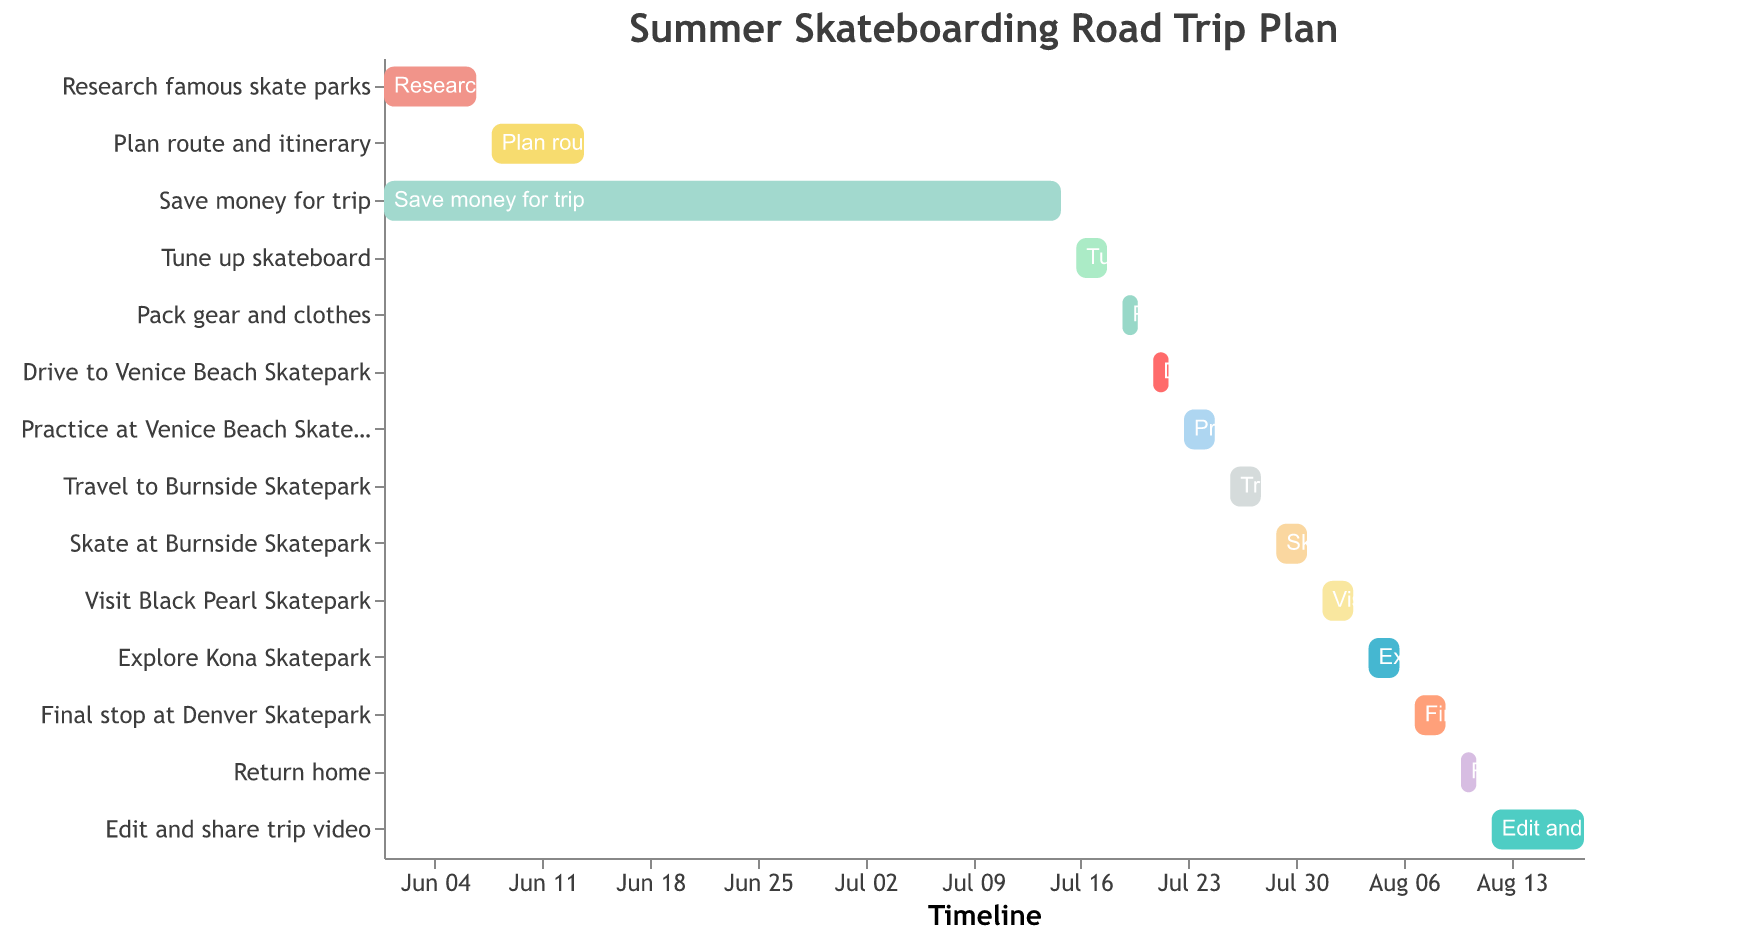How long is the "Save money for trip" task? Find the "Save money for trip" bar and check the duration in the corresponding row.
Answer: 45 days What is the first task in the planning process? The figure's y-axis lists tasks chronologically from top to bottom. The top task is "Research famous skate parks".
Answer: Research famous skate parks Which task has the shortest duration? Compare the durations listed for all tasks. "Pack gear and clothes" has the shortest duration of 2 days.
Answer: Pack gear and clothes What is the total duration of the travel tasks? Sum the durations of the travel-related tasks: Drive to Venice Beach Skatepark (2) + Travel to Burnside Skatepark (3) + Return home (2) = 7.
Answer: 7 days Which task ends latest in August? Check the end dates of tasks listed in August. The last task "Edit and share trip video" ends on August 18.
Answer: Edit and share trip video How many days after tuning up the skateboard does the packing start? "Tune up skateboard" ends on July 18 and "Pack gear and clothes" starts on July 19. Calculate the days between: July 19 - July 18 = 1 day.
Answer: 1 day Which two tasks overlap with each other in June? Identify tasks in June and see if their dates overlap. "Research famous skate parks" (June 1-7) overlaps with "Save money for trip" (June 1 - July 15).
Answer: Research famous skate parks and Save money for trip Which skate park do you visit right after Burnside Skatepark? Refer to tasks involving visits to named skate parks. Right after "Skate at Burnside Skatepark", you visit "Visit Black Pearl Skatepark".
Answer: Black Pearl Skatepark What is the time gap between traveling to Burnside and skating at Burnside? "Travel to Burnside Skatepark" ends on July 28, and "Skate at Burnside Skatepark" starts on July 29. The gap is 1 day.
Answer: 1 day From the start of the trip (June 1) to the end of the trip (August 18), how many days does the entire plan span? Count the days from June 1 to August 18. Total duration from start to end: 79 days.
Answer: 79 days 